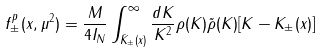Convert formula to latex. <formula><loc_0><loc_0><loc_500><loc_500>f _ { \pm } ^ { p } ( x , { \mu } ^ { 2 } ) = { \frac { M } { 4 I _ { N } } } \int _ { { \bar { K } } _ { \pm } ( x ) } ^ { \infty } { \frac { d K } { K ^ { 2 } } } \rho ( K ) { \tilde { \rho } } ( K ) [ K - K _ { \pm } ( x ) ]</formula> 